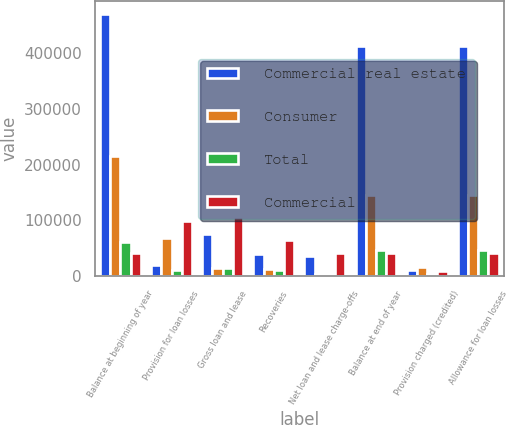<chart> <loc_0><loc_0><loc_500><loc_500><stacked_bar_chart><ecel><fcel>Balance at beginning of year<fcel>Provision for loan losses<fcel>Gross loan and lease<fcel>Recoveries<fcel>Net loan and lease charge-offs<fcel>Balance at end of year<fcel>Provision charged (credited)<fcel>Allowance for loan losses<nl><fcel>Commercial real estate<fcel>469213<fcel>19691<fcel>76345<fcel>40546<fcel>35799<fcel>412514<fcel>10586<fcel>412514<nl><fcel>Consumer<fcel>216012<fcel>67825<fcel>15322<fcel>12144<fcel>3178<fcel>145009<fcel>15968<fcel>145009<nl><fcel>Total<fcel>61066<fcel>10566<fcel>14543<fcel>11279<fcel>3264<fcel>47140<fcel>3247<fcel>47140<nl><fcel>Commercial<fcel>42241<fcel>98082<fcel>106210<fcel>63969<fcel>42241<fcel>42241<fcel>8629<fcel>42241<nl></chart> 